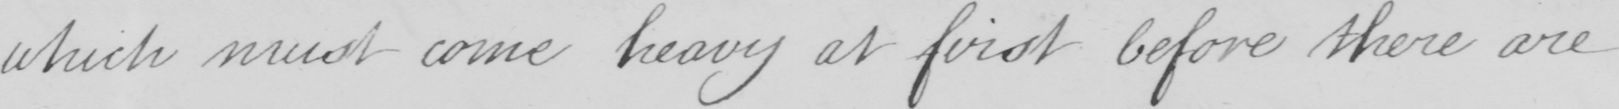Please provide the text content of this handwritten line. which must come heavy at first before there are 